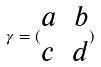Convert formula to latex. <formula><loc_0><loc_0><loc_500><loc_500>\gamma = ( \begin{matrix} a & b \\ c & d \end{matrix} )</formula> 